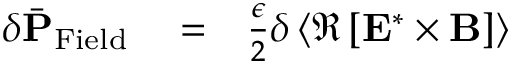<formula> <loc_0><loc_0><loc_500><loc_500>\begin{array} { r l r } { \delta \bar { P } _ { F i e l d } } & = } & { \frac { \epsilon } { 2 } \delta \left \langle \Re \left [ { E } ^ { * } \times { B } \right ] \right \rangle } \end{array}</formula> 